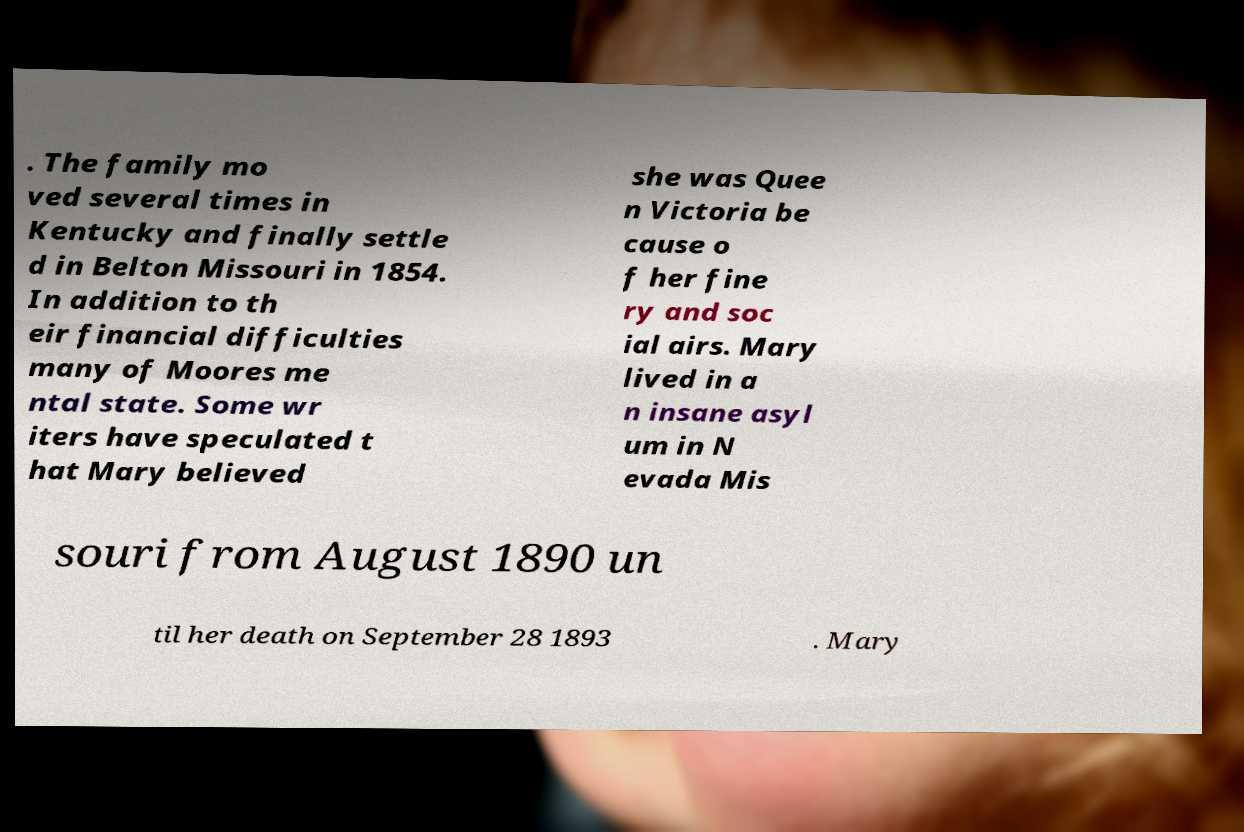What historical context does the text in the image provide about the family's movements? The text mentions that the family relocated several times in Kentucky and eventually settled in Belton, Missouri, in 1854. This movement could be reflective of the broader 19th-century patterns of migration and settlement in the United States, often influenced by economic opportunities or social pressures. 